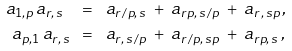<formula> <loc_0><loc_0><loc_500><loc_500>a _ { 1 , p } \, a _ { r , \, s } \ \ & = \ \ a _ { r \, / p , \, s } \ + \ a _ { r p , \, s \, / p } \ + \ a _ { r \, , \, s p } \, , \\ a _ { p , 1 } \, a _ { r , \, s } \ \ & = \ \ a _ { r , \, s \, / p } \ + \ a _ { r \, / p , \, s p } \ + \ a _ { r p , \, s } \, ,</formula> 